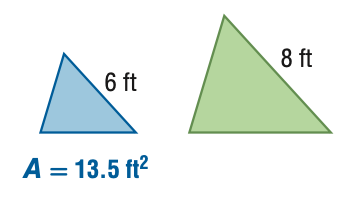Answer the mathemtical geometry problem and directly provide the correct option letter.
Question: For the pair of similar figures, find the area of the green figure.
Choices: A: 7.6 B: 10.1 C: 18 D: 24 D 